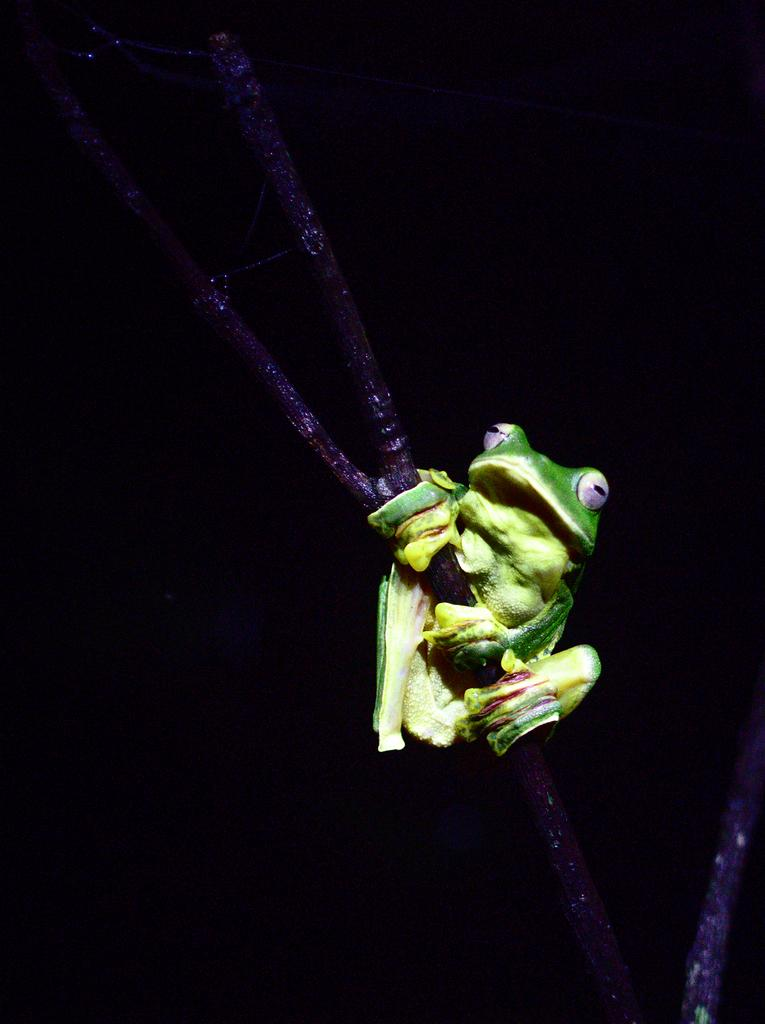What is the main subject in the foreground of the image? There is a toy frog in the foreground of the image. What is the toy frog holding in its hands? The toy frog is holding a stem in the image. What can be observed about the background of the image? The background of the image is dark. What type of corn can be seen growing in the background of the image? There is no corn visible in the image; the background is dark. 